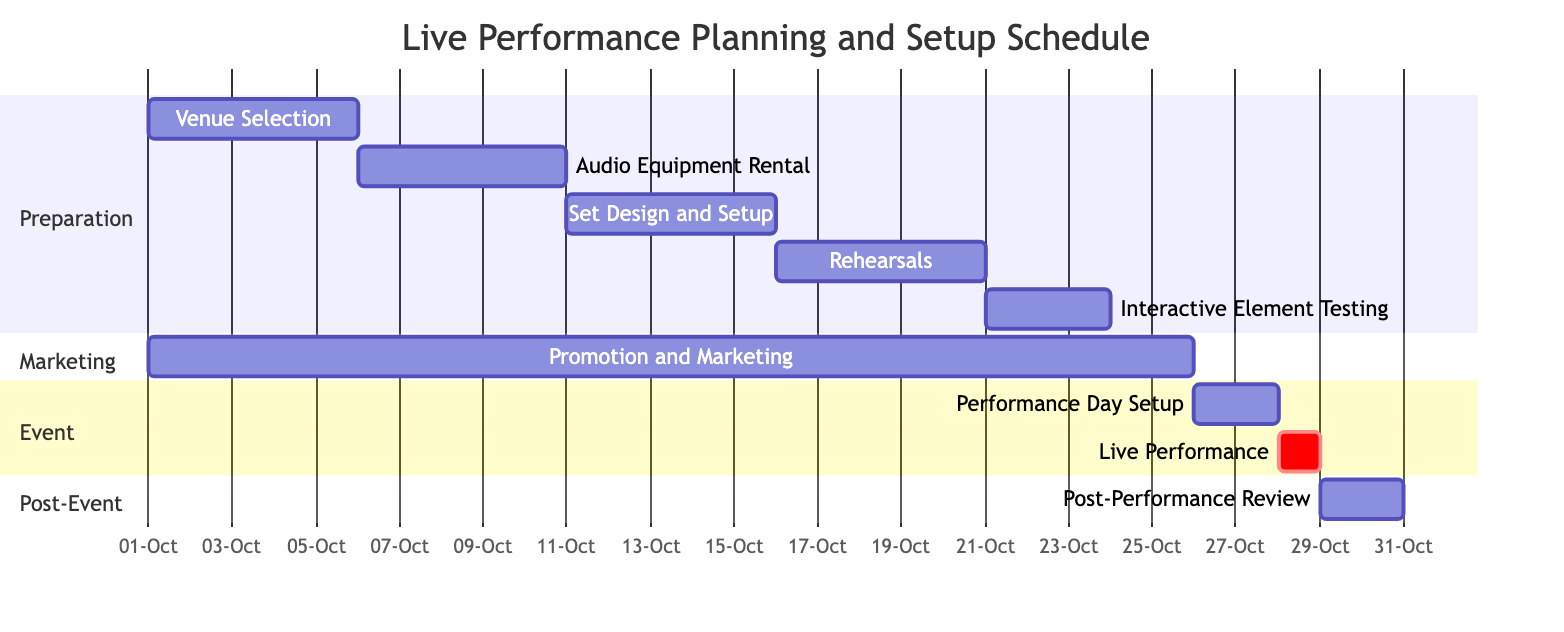What is the duration of the audio equipment rental task? The duration of the "Audio Equipment Rental" task is determined by subtracting the start date (October 6, 2023) from the end date (October 10, 2023). This results in a total of 5 days.
Answer: 5 days How many tasks are scheduled in the preparation section? The preparation section includes the following tasks: Venue Selection, Audio Equipment Rental, Set Design and Setup, Rehearsals, and Interactive Element Testing. Counting these tasks gives a total of 5 tasks.
Answer: 5 tasks What task starts immediately after the set design and setup? The task "Rehearsals" starts immediately after "Set Design and Setup". The latter ends on October 15, 2023, while "Rehearsals" begins on October 16, 2023.
Answer: Rehearsals When is the performance day scheduled? The performance day is scheduled for October 28, 2023, as indicated by the start and end date of the "Live Performance" task, which both fall on this date.
Answer: October 28, 2023 Which task overlaps with the promotion and marketing task? The "Promotion and Marketing" task runs from October 1 to October 25, which overlaps with the tasks "Venue Selection," "Audio Equipment Rental," "Set Design and Setup," "Rehearsals," and "Interactive Element Testing." After analyzing the dates, the maximum overlap occurs with the "Set Design and Setup."
Answer: Set Design and Setup How many days are allocated for post-performance review? The duration of the "Post-Performance Review" task spans from October 29 to October 30, 2023. Subtracting the start date from the end date indicates there are 2 days allocated for this task.
Answer: 2 days What is the sequence of tasks from preparation to the live performance? The sequence starts with "Venue Selection," followed by "Audio Equipment Rental," then "Set Design and Setup," continuing with "Rehearsals," leading to "Interactive Element Testing," proceeding to "Performance Day Setup," and lastly culminates in the "Live Performance".
Answer: Venue Selection, Audio Equipment Rental, Set Design and Setup, Rehearsals, Interactive Element Testing, Performance Day Setup, Live Performance Where does the interactive element testing task fit in the overall schedule? The "Interactive Element Testing" task is scheduled after the "Rehearsals" task and before the "Performance Day Setup." It takes place from October 21 to October 23, 2023.
Answer: Between Rehearsals and Performance Day Setup 